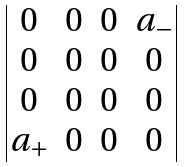<formula> <loc_0><loc_0><loc_500><loc_500>\begin{vmatrix} 0 & 0 & 0 & a _ { - } \\ 0 & 0 & 0 & 0 \\ 0 & 0 & 0 & 0 \\ a _ { + } & 0 & 0 & 0 \\ \end{vmatrix}</formula> 